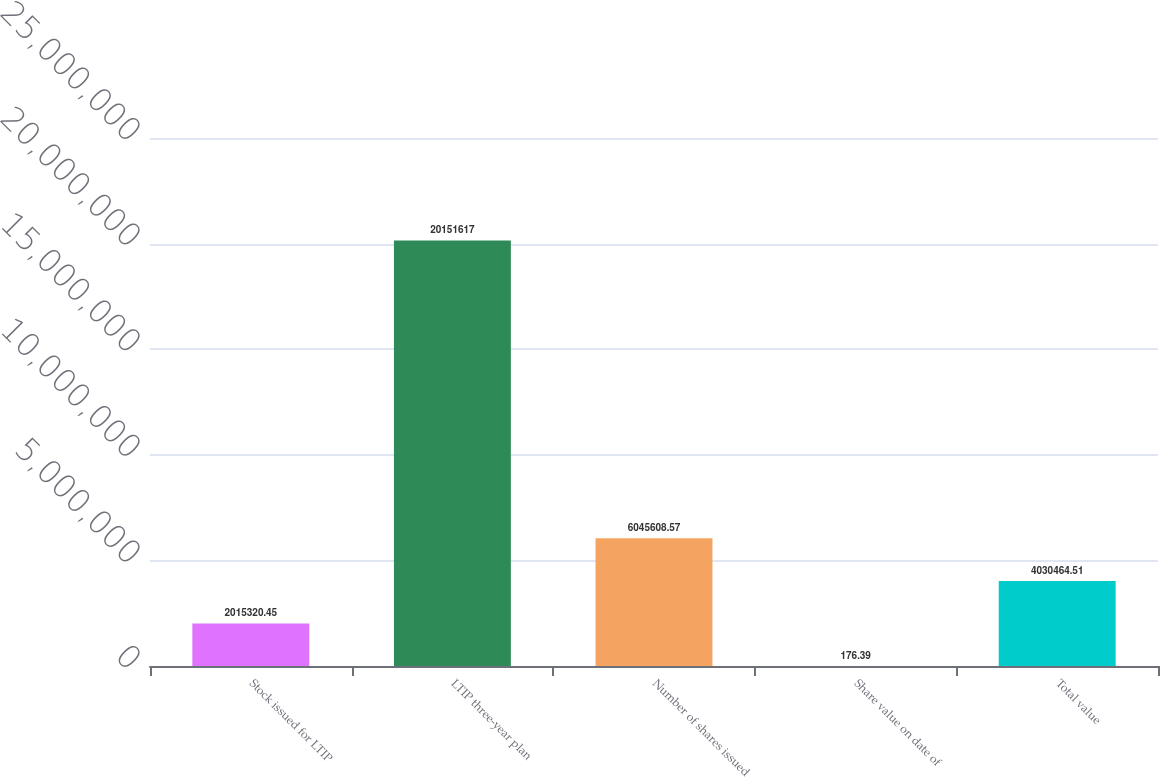Convert chart. <chart><loc_0><loc_0><loc_500><loc_500><bar_chart><fcel>Stock issued for LTIP<fcel>LTIP three-year plan<fcel>Number of shares issued<fcel>Share value on date of<fcel>Total value<nl><fcel>2.01532e+06<fcel>2.01516e+07<fcel>6.04561e+06<fcel>176.39<fcel>4.03046e+06<nl></chart> 